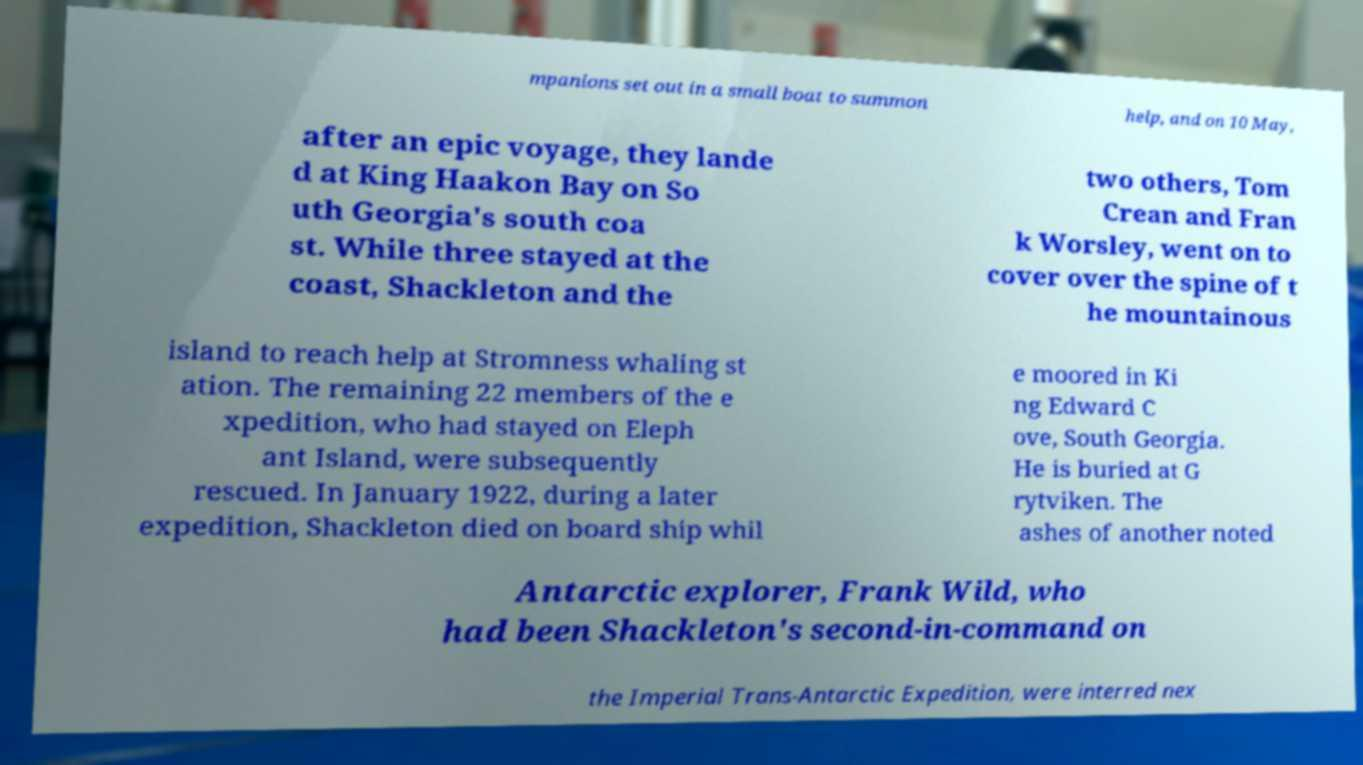Please identify and transcribe the text found in this image. mpanions set out in a small boat to summon help, and on 10 May, after an epic voyage, they lande d at King Haakon Bay on So uth Georgia's south coa st. While three stayed at the coast, Shackleton and the two others, Tom Crean and Fran k Worsley, went on to cover over the spine of t he mountainous island to reach help at Stromness whaling st ation. The remaining 22 members of the e xpedition, who had stayed on Eleph ant Island, were subsequently rescued. In January 1922, during a later expedition, Shackleton died on board ship whil e moored in Ki ng Edward C ove, South Georgia. He is buried at G rytviken. The ashes of another noted Antarctic explorer, Frank Wild, who had been Shackleton's second-in-command on the Imperial Trans-Antarctic Expedition, were interred nex 